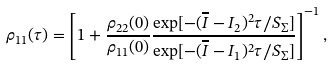<formula> <loc_0><loc_0><loc_500><loc_500>\rho _ { 1 1 } ( \tau ) = \left [ 1 + \frac { \rho _ { 2 2 } ( 0 ) } { \rho _ { 1 1 } ( 0 ) } \frac { \exp [ - ( \overline { I } - I _ { 2 } ) ^ { 2 } \tau / S _ { \Sigma } ] } { \exp [ - ( \overline { I } - I _ { 1 } ) ^ { 2 } \tau / S _ { \Sigma } ] } \right ] ^ { - 1 } ,</formula> 